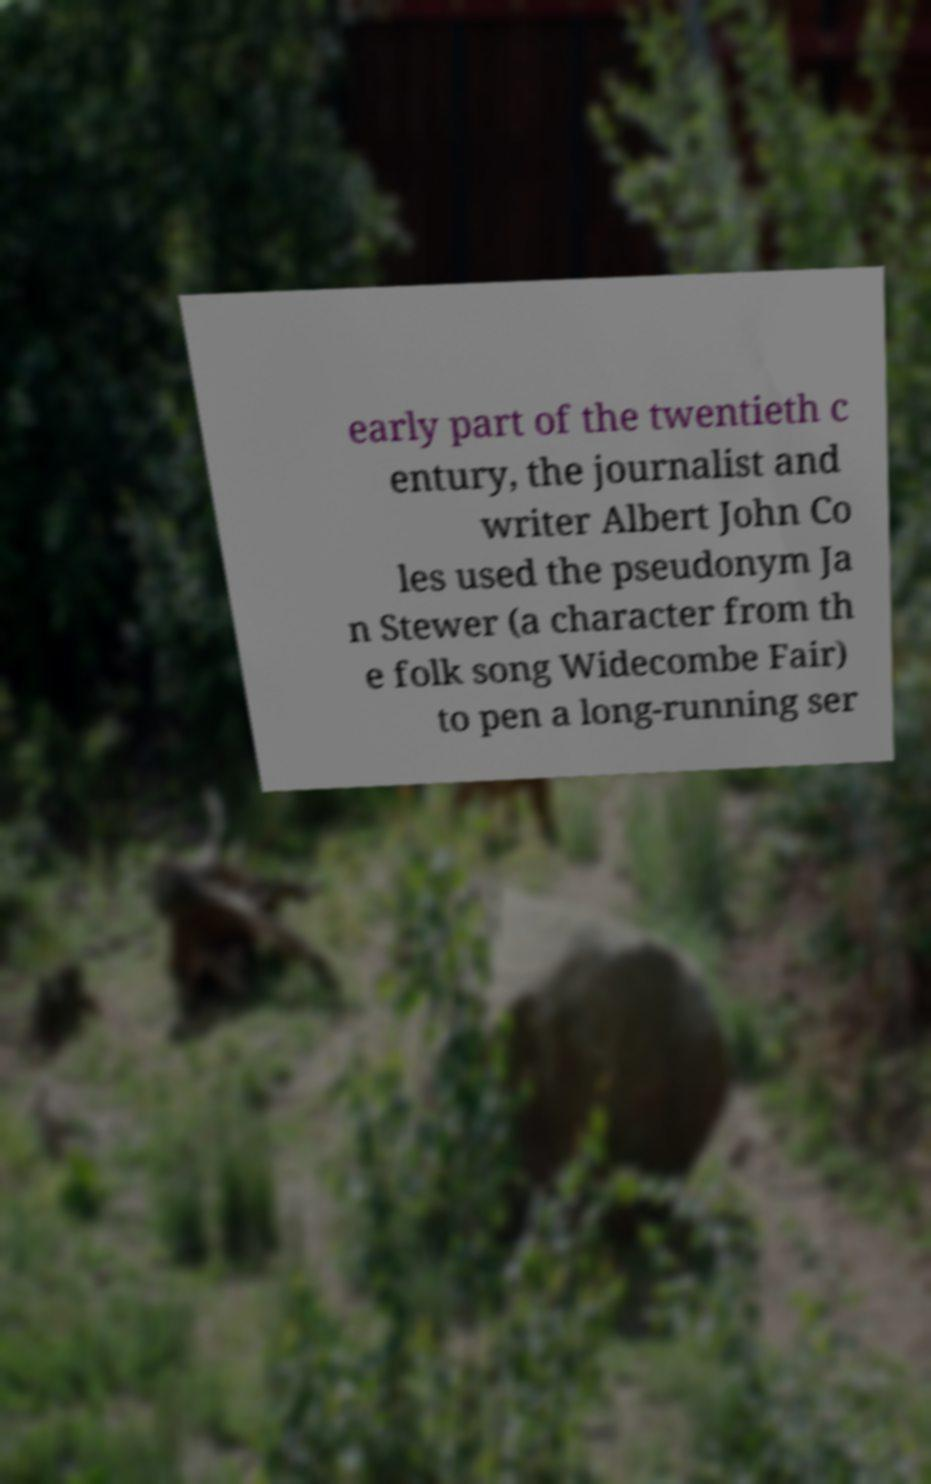Please read and relay the text visible in this image. What does it say? early part of the twentieth c entury, the journalist and writer Albert John Co les used the pseudonym Ja n Stewer (a character from th e folk song Widecombe Fair) to pen a long-running ser 